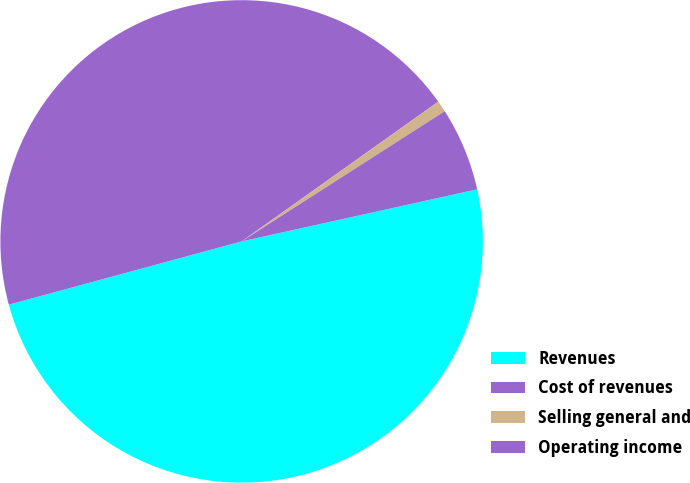Convert chart. <chart><loc_0><loc_0><loc_500><loc_500><pie_chart><fcel>Revenues<fcel>Cost of revenues<fcel>Selling general and<fcel>Operating income<nl><fcel>49.24%<fcel>44.39%<fcel>0.76%<fcel>5.61%<nl></chart> 